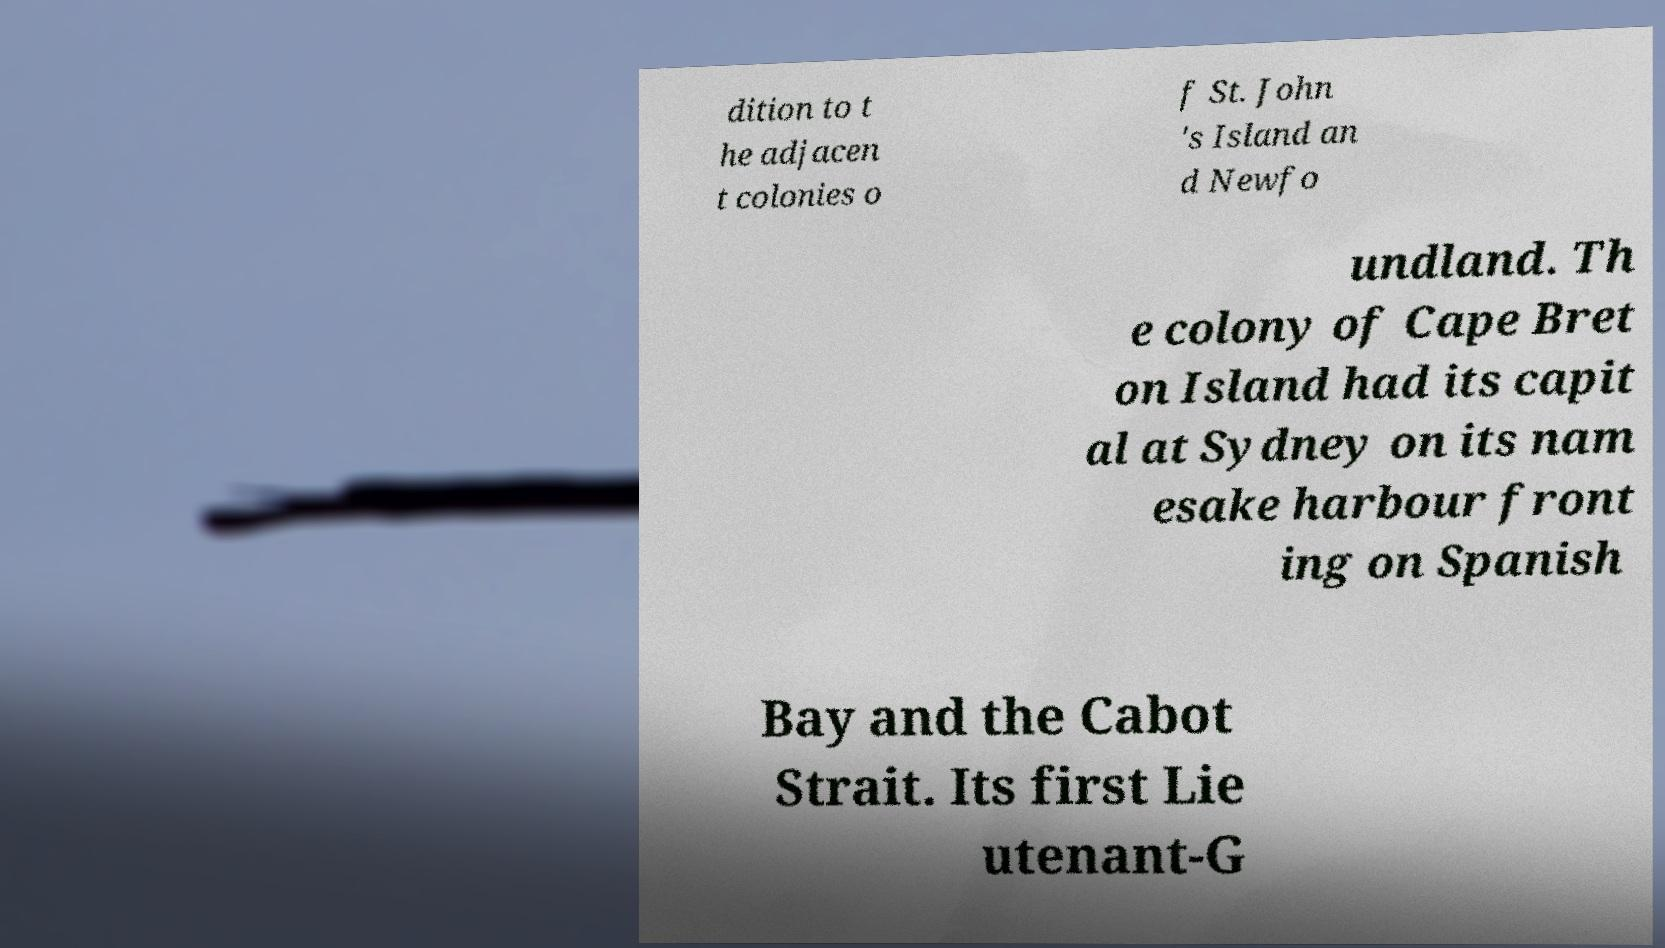I need the written content from this picture converted into text. Can you do that? dition to t he adjacen t colonies o f St. John 's Island an d Newfo undland. Th e colony of Cape Bret on Island had its capit al at Sydney on its nam esake harbour front ing on Spanish Bay and the Cabot Strait. Its first Lie utenant-G 